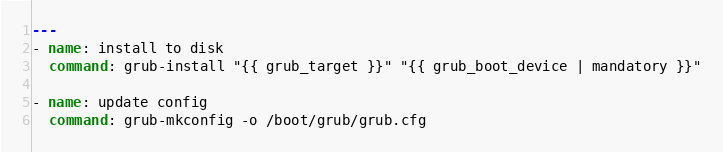<code> <loc_0><loc_0><loc_500><loc_500><_YAML_>---
- name: install to disk
  command: grub-install "{{ grub_target }}" "{{ grub_boot_device | mandatory }}"

- name: update config
  command: grub-mkconfig -o /boot/grub/grub.cfg
</code> 